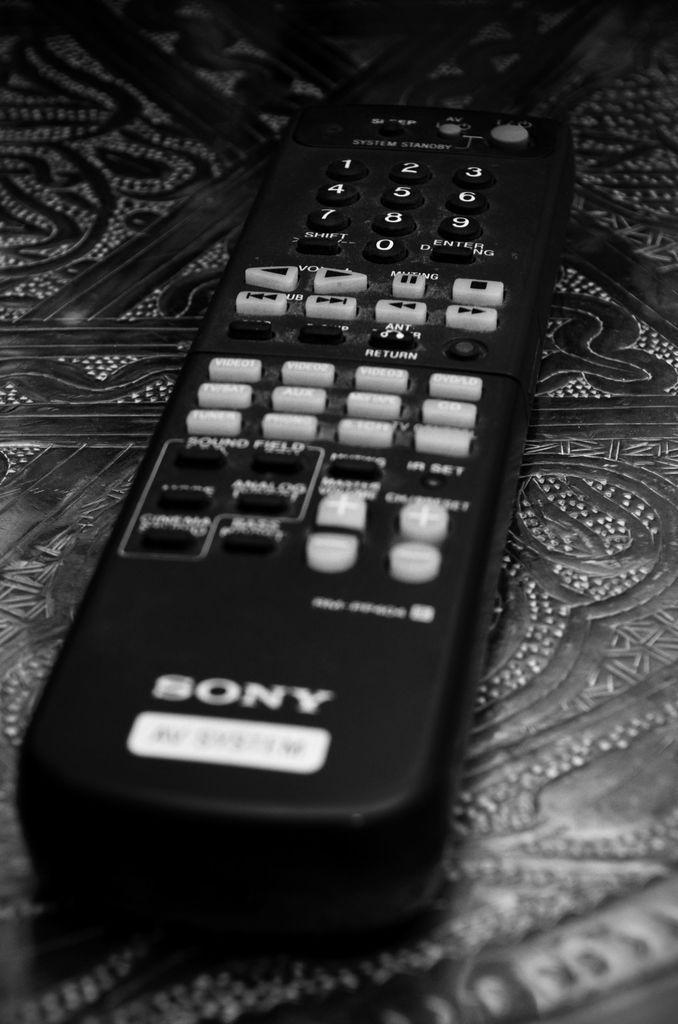Could you give a brief overview of what you see in this image? In this image I can see the remote and the remote is on the surface and the image is in black and white. 